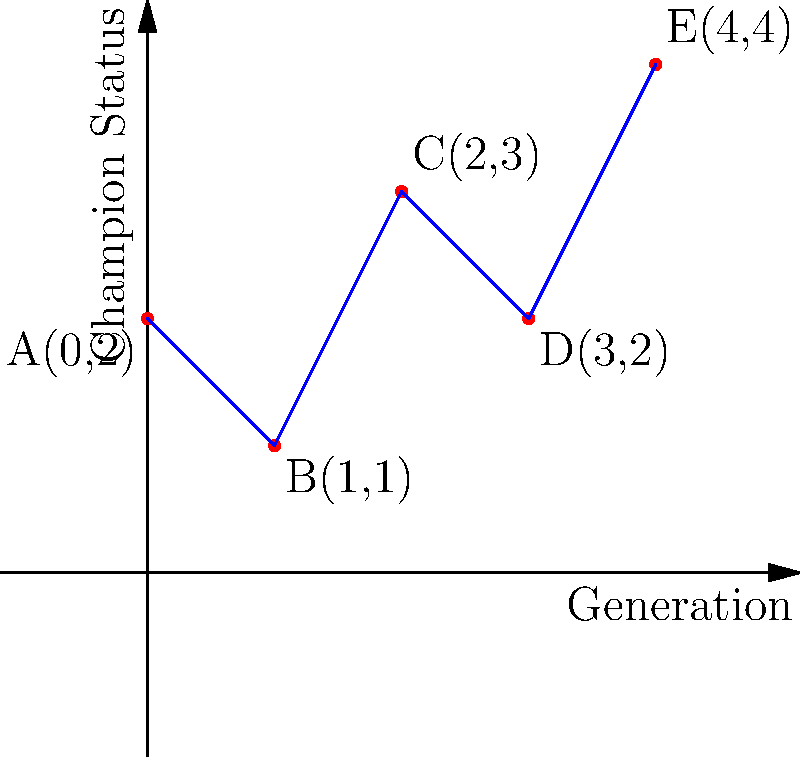In a pedigree chart for a champion bloodline, each point represents a dog's generation and champion status. The x-coordinate represents the generation (0 being the oldest), and the y-coordinate represents the champion status (higher values indicate more prestigious titles). Given the pedigree chart above, calculate the slope between points A and E. What does this value represent in terms of the bloodline's overall improvement? To solve this problem, we'll follow these steps:

1. Identify the coordinates of points A and E:
   Point A: (0, 2)
   Point E: (4, 4)

2. Calculate the slope using the slope formula:
   $$ \text{Slope} = \frac{y_2 - y_1}{x_2 - x_1} $$

3. Plug in the values:
   $$ \text{Slope} = \frac{4 - 2}{4 - 0} = \frac{2}{4} = 0.5 $$

4. Interpret the result:
   The slope of 0.5 represents the rate of improvement in champion status per generation. A positive slope indicates an overall improvement in the bloodline's champion status over time.

5. In the context of dog shows:
   This slope suggests that, on average, each generation in this bloodline improves its champion status by 0.5 units. This could represent achieving higher titles or more prestigious wins in conformation events.
Answer: Slope = 0.5, representing an average improvement of 0.5 in champion status per generation. 